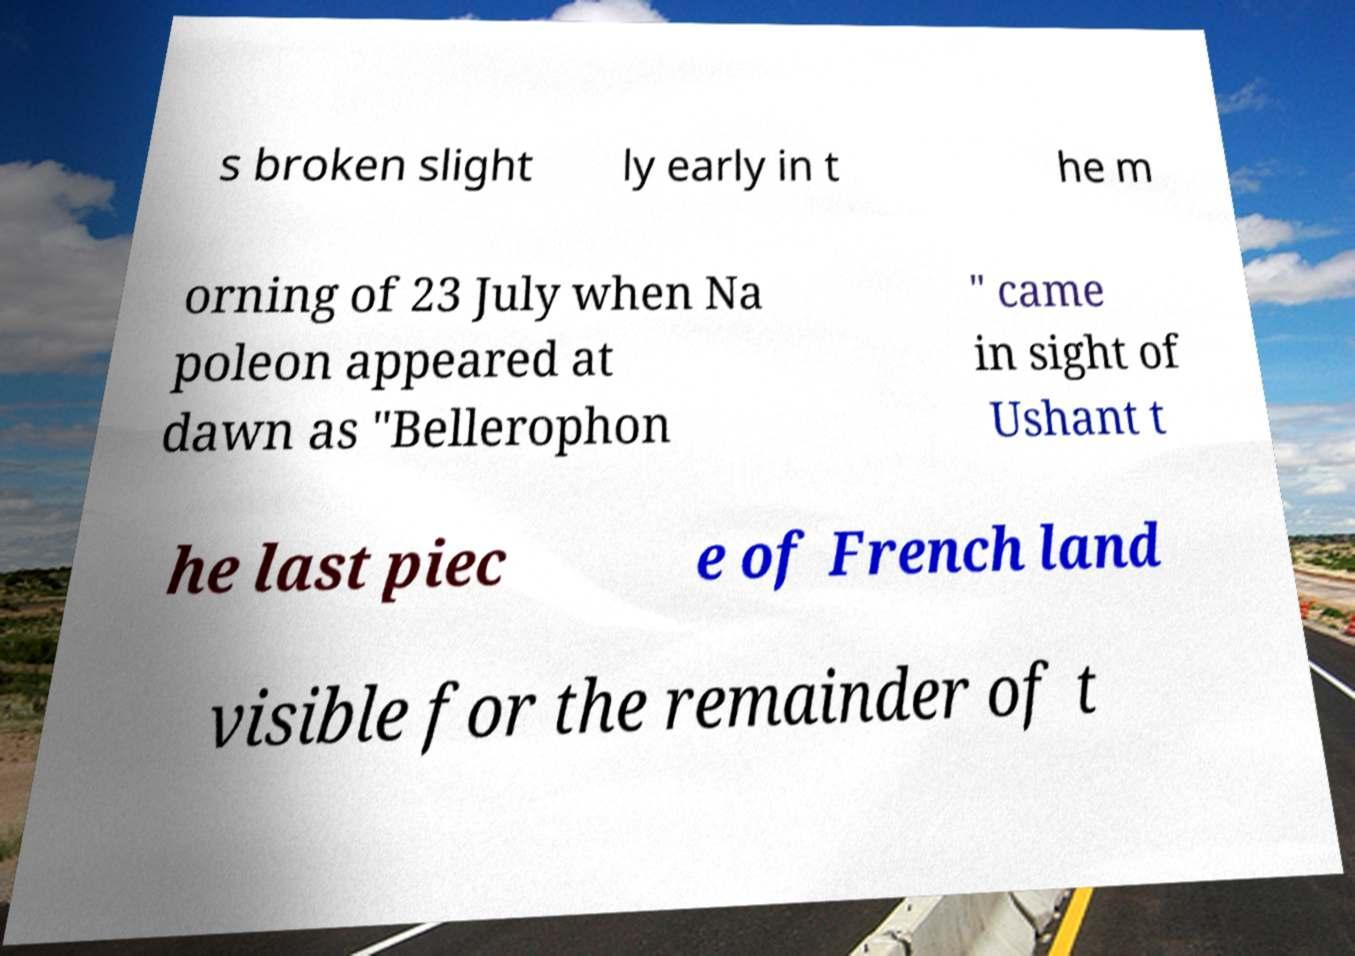Can you accurately transcribe the text from the provided image for me? s broken slight ly early in t he m orning of 23 July when Na poleon appeared at dawn as "Bellerophon " came in sight of Ushant t he last piec e of French land visible for the remainder of t 